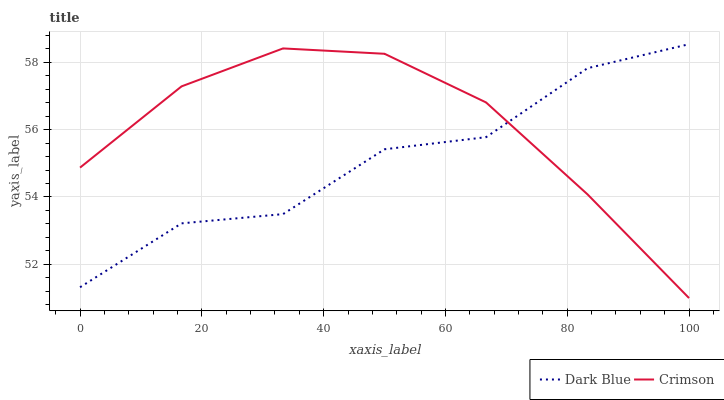Does Dark Blue have the minimum area under the curve?
Answer yes or no. Yes. Does Crimson have the maximum area under the curve?
Answer yes or no. Yes. Does Dark Blue have the maximum area under the curve?
Answer yes or no. No. Is Crimson the smoothest?
Answer yes or no. Yes. Is Dark Blue the roughest?
Answer yes or no. Yes. Is Dark Blue the smoothest?
Answer yes or no. No. Does Dark Blue have the lowest value?
Answer yes or no. No. Does Dark Blue have the highest value?
Answer yes or no. Yes. 